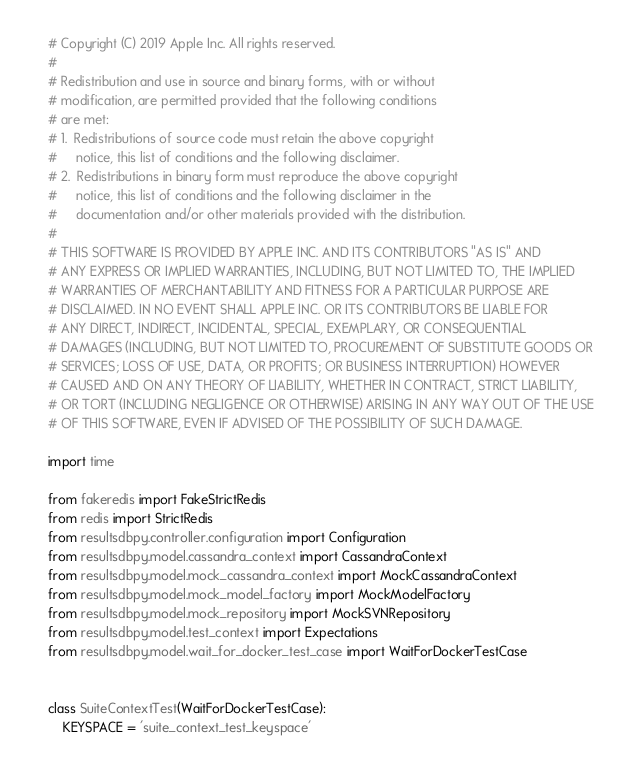<code> <loc_0><loc_0><loc_500><loc_500><_Python_># Copyright (C) 2019 Apple Inc. All rights reserved.
#
# Redistribution and use in source and binary forms, with or without
# modification, are permitted provided that the following conditions
# are met:
# 1.  Redistributions of source code must retain the above copyright
#     notice, this list of conditions and the following disclaimer.
# 2.  Redistributions in binary form must reproduce the above copyright
#     notice, this list of conditions and the following disclaimer in the
#     documentation and/or other materials provided with the distribution.
#
# THIS SOFTWARE IS PROVIDED BY APPLE INC. AND ITS CONTRIBUTORS "AS IS" AND
# ANY EXPRESS OR IMPLIED WARRANTIES, INCLUDING, BUT NOT LIMITED TO, THE IMPLIED
# WARRANTIES OF MERCHANTABILITY AND FITNESS FOR A PARTICULAR PURPOSE ARE
# DISCLAIMED. IN NO EVENT SHALL APPLE INC. OR ITS CONTRIBUTORS BE LIABLE FOR
# ANY DIRECT, INDIRECT, INCIDENTAL, SPECIAL, EXEMPLARY, OR CONSEQUENTIAL
# DAMAGES (INCLUDING, BUT NOT LIMITED TO, PROCUREMENT OF SUBSTITUTE GOODS OR
# SERVICES; LOSS OF USE, DATA, OR PROFITS; OR BUSINESS INTERRUPTION) HOWEVER
# CAUSED AND ON ANY THEORY OF LIABILITY, WHETHER IN CONTRACT, STRICT LIABILITY,
# OR TORT (INCLUDING NEGLIGENCE OR OTHERWISE) ARISING IN ANY WAY OUT OF THE USE
# OF THIS SOFTWARE, EVEN IF ADVISED OF THE POSSIBILITY OF SUCH DAMAGE.

import time

from fakeredis import FakeStrictRedis
from redis import StrictRedis
from resultsdbpy.controller.configuration import Configuration
from resultsdbpy.model.cassandra_context import CassandraContext
from resultsdbpy.model.mock_cassandra_context import MockCassandraContext
from resultsdbpy.model.mock_model_factory import MockModelFactory
from resultsdbpy.model.mock_repository import MockSVNRepository
from resultsdbpy.model.test_context import Expectations
from resultsdbpy.model.wait_for_docker_test_case import WaitForDockerTestCase


class SuiteContextTest(WaitForDockerTestCase):
    KEYSPACE = 'suite_context_test_keyspace'
</code> 